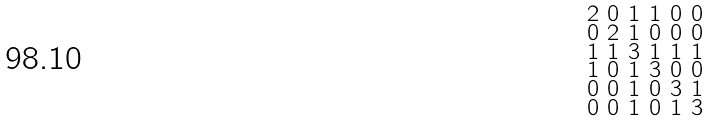<formula> <loc_0><loc_0><loc_500><loc_500>\begin{smallmatrix} 2 & 0 & 1 & 1 & 0 & 0 \\ 0 & 2 & 1 & 0 & 0 & 0 \\ 1 & 1 & 3 & 1 & 1 & 1 \\ 1 & 0 & 1 & 3 & 0 & 0 \\ 0 & 0 & 1 & 0 & 3 & 1 \\ 0 & 0 & 1 & 0 & 1 & 3 \end{smallmatrix}</formula> 